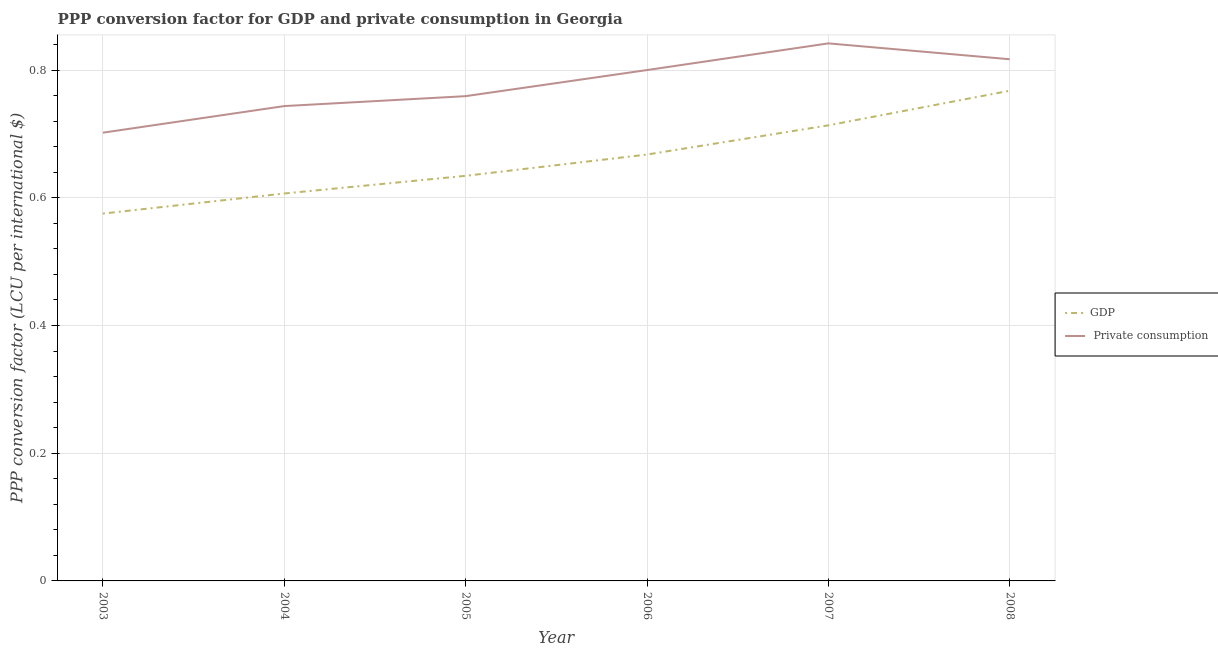What is the ppp conversion factor for gdp in 2003?
Ensure brevity in your answer.  0.58. Across all years, what is the maximum ppp conversion factor for gdp?
Keep it short and to the point. 0.77. Across all years, what is the minimum ppp conversion factor for gdp?
Give a very brief answer. 0.58. What is the total ppp conversion factor for gdp in the graph?
Your answer should be very brief. 3.97. What is the difference between the ppp conversion factor for gdp in 2005 and that in 2006?
Offer a very short reply. -0.03. What is the difference between the ppp conversion factor for gdp in 2003 and the ppp conversion factor for private consumption in 2006?
Your answer should be very brief. -0.22. What is the average ppp conversion factor for gdp per year?
Offer a very short reply. 0.66. In the year 2007, what is the difference between the ppp conversion factor for private consumption and ppp conversion factor for gdp?
Give a very brief answer. 0.13. In how many years, is the ppp conversion factor for gdp greater than 0.32 LCU?
Your response must be concise. 6. What is the ratio of the ppp conversion factor for gdp in 2006 to that in 2008?
Offer a very short reply. 0.87. Is the difference between the ppp conversion factor for gdp in 2005 and 2006 greater than the difference between the ppp conversion factor for private consumption in 2005 and 2006?
Your answer should be very brief. Yes. What is the difference between the highest and the second highest ppp conversion factor for gdp?
Make the answer very short. 0.05. What is the difference between the highest and the lowest ppp conversion factor for private consumption?
Make the answer very short. 0.14. Is the ppp conversion factor for gdp strictly greater than the ppp conversion factor for private consumption over the years?
Ensure brevity in your answer.  No. Is the ppp conversion factor for gdp strictly less than the ppp conversion factor for private consumption over the years?
Give a very brief answer. Yes. How many lines are there?
Make the answer very short. 2. How many years are there in the graph?
Offer a very short reply. 6. Are the values on the major ticks of Y-axis written in scientific E-notation?
Your response must be concise. No. How are the legend labels stacked?
Ensure brevity in your answer.  Vertical. What is the title of the graph?
Your answer should be compact. PPP conversion factor for GDP and private consumption in Georgia. What is the label or title of the X-axis?
Offer a very short reply. Year. What is the label or title of the Y-axis?
Offer a terse response. PPP conversion factor (LCU per international $). What is the PPP conversion factor (LCU per international $) of GDP in 2003?
Offer a terse response. 0.58. What is the PPP conversion factor (LCU per international $) of  Private consumption in 2003?
Offer a very short reply. 0.7. What is the PPP conversion factor (LCU per international $) in GDP in 2004?
Your answer should be very brief. 0.61. What is the PPP conversion factor (LCU per international $) in  Private consumption in 2004?
Provide a succinct answer. 0.74. What is the PPP conversion factor (LCU per international $) in GDP in 2005?
Provide a succinct answer. 0.63. What is the PPP conversion factor (LCU per international $) in  Private consumption in 2005?
Your answer should be very brief. 0.76. What is the PPP conversion factor (LCU per international $) in GDP in 2006?
Provide a succinct answer. 0.67. What is the PPP conversion factor (LCU per international $) in  Private consumption in 2006?
Your response must be concise. 0.8. What is the PPP conversion factor (LCU per international $) in GDP in 2007?
Keep it short and to the point. 0.71. What is the PPP conversion factor (LCU per international $) of  Private consumption in 2007?
Provide a short and direct response. 0.84. What is the PPP conversion factor (LCU per international $) in GDP in 2008?
Ensure brevity in your answer.  0.77. What is the PPP conversion factor (LCU per international $) in  Private consumption in 2008?
Keep it short and to the point. 0.82. Across all years, what is the maximum PPP conversion factor (LCU per international $) in GDP?
Offer a very short reply. 0.77. Across all years, what is the maximum PPP conversion factor (LCU per international $) in  Private consumption?
Your answer should be compact. 0.84. Across all years, what is the minimum PPP conversion factor (LCU per international $) of GDP?
Provide a succinct answer. 0.58. Across all years, what is the minimum PPP conversion factor (LCU per international $) in  Private consumption?
Your answer should be compact. 0.7. What is the total PPP conversion factor (LCU per international $) of GDP in the graph?
Ensure brevity in your answer.  3.97. What is the total PPP conversion factor (LCU per international $) of  Private consumption in the graph?
Make the answer very short. 4.66. What is the difference between the PPP conversion factor (LCU per international $) in GDP in 2003 and that in 2004?
Provide a succinct answer. -0.03. What is the difference between the PPP conversion factor (LCU per international $) of  Private consumption in 2003 and that in 2004?
Your answer should be compact. -0.04. What is the difference between the PPP conversion factor (LCU per international $) of GDP in 2003 and that in 2005?
Give a very brief answer. -0.06. What is the difference between the PPP conversion factor (LCU per international $) of  Private consumption in 2003 and that in 2005?
Ensure brevity in your answer.  -0.06. What is the difference between the PPP conversion factor (LCU per international $) in GDP in 2003 and that in 2006?
Offer a terse response. -0.09. What is the difference between the PPP conversion factor (LCU per international $) in  Private consumption in 2003 and that in 2006?
Ensure brevity in your answer.  -0.1. What is the difference between the PPP conversion factor (LCU per international $) in GDP in 2003 and that in 2007?
Your answer should be compact. -0.14. What is the difference between the PPP conversion factor (LCU per international $) of  Private consumption in 2003 and that in 2007?
Keep it short and to the point. -0.14. What is the difference between the PPP conversion factor (LCU per international $) of GDP in 2003 and that in 2008?
Your answer should be compact. -0.19. What is the difference between the PPP conversion factor (LCU per international $) of  Private consumption in 2003 and that in 2008?
Make the answer very short. -0.12. What is the difference between the PPP conversion factor (LCU per international $) in GDP in 2004 and that in 2005?
Make the answer very short. -0.03. What is the difference between the PPP conversion factor (LCU per international $) in  Private consumption in 2004 and that in 2005?
Offer a terse response. -0.02. What is the difference between the PPP conversion factor (LCU per international $) of GDP in 2004 and that in 2006?
Keep it short and to the point. -0.06. What is the difference between the PPP conversion factor (LCU per international $) in  Private consumption in 2004 and that in 2006?
Provide a succinct answer. -0.06. What is the difference between the PPP conversion factor (LCU per international $) of GDP in 2004 and that in 2007?
Ensure brevity in your answer.  -0.11. What is the difference between the PPP conversion factor (LCU per international $) in  Private consumption in 2004 and that in 2007?
Your answer should be very brief. -0.1. What is the difference between the PPP conversion factor (LCU per international $) of GDP in 2004 and that in 2008?
Provide a succinct answer. -0.16. What is the difference between the PPP conversion factor (LCU per international $) of  Private consumption in 2004 and that in 2008?
Give a very brief answer. -0.07. What is the difference between the PPP conversion factor (LCU per international $) in GDP in 2005 and that in 2006?
Your answer should be compact. -0.03. What is the difference between the PPP conversion factor (LCU per international $) of  Private consumption in 2005 and that in 2006?
Your response must be concise. -0.04. What is the difference between the PPP conversion factor (LCU per international $) in GDP in 2005 and that in 2007?
Ensure brevity in your answer.  -0.08. What is the difference between the PPP conversion factor (LCU per international $) of  Private consumption in 2005 and that in 2007?
Your answer should be compact. -0.08. What is the difference between the PPP conversion factor (LCU per international $) in GDP in 2005 and that in 2008?
Your answer should be compact. -0.13. What is the difference between the PPP conversion factor (LCU per international $) of  Private consumption in 2005 and that in 2008?
Offer a terse response. -0.06. What is the difference between the PPP conversion factor (LCU per international $) of GDP in 2006 and that in 2007?
Offer a terse response. -0.05. What is the difference between the PPP conversion factor (LCU per international $) in  Private consumption in 2006 and that in 2007?
Keep it short and to the point. -0.04. What is the difference between the PPP conversion factor (LCU per international $) in GDP in 2006 and that in 2008?
Your response must be concise. -0.1. What is the difference between the PPP conversion factor (LCU per international $) in  Private consumption in 2006 and that in 2008?
Your answer should be very brief. -0.02. What is the difference between the PPP conversion factor (LCU per international $) in GDP in 2007 and that in 2008?
Give a very brief answer. -0.05. What is the difference between the PPP conversion factor (LCU per international $) in  Private consumption in 2007 and that in 2008?
Your answer should be compact. 0.02. What is the difference between the PPP conversion factor (LCU per international $) in GDP in 2003 and the PPP conversion factor (LCU per international $) in  Private consumption in 2004?
Provide a succinct answer. -0.17. What is the difference between the PPP conversion factor (LCU per international $) of GDP in 2003 and the PPP conversion factor (LCU per international $) of  Private consumption in 2005?
Your response must be concise. -0.18. What is the difference between the PPP conversion factor (LCU per international $) of GDP in 2003 and the PPP conversion factor (LCU per international $) of  Private consumption in 2006?
Offer a very short reply. -0.22. What is the difference between the PPP conversion factor (LCU per international $) of GDP in 2003 and the PPP conversion factor (LCU per international $) of  Private consumption in 2007?
Provide a short and direct response. -0.27. What is the difference between the PPP conversion factor (LCU per international $) in GDP in 2003 and the PPP conversion factor (LCU per international $) in  Private consumption in 2008?
Provide a succinct answer. -0.24. What is the difference between the PPP conversion factor (LCU per international $) in GDP in 2004 and the PPP conversion factor (LCU per international $) in  Private consumption in 2005?
Ensure brevity in your answer.  -0.15. What is the difference between the PPP conversion factor (LCU per international $) in GDP in 2004 and the PPP conversion factor (LCU per international $) in  Private consumption in 2006?
Keep it short and to the point. -0.19. What is the difference between the PPP conversion factor (LCU per international $) of GDP in 2004 and the PPP conversion factor (LCU per international $) of  Private consumption in 2007?
Make the answer very short. -0.24. What is the difference between the PPP conversion factor (LCU per international $) of GDP in 2004 and the PPP conversion factor (LCU per international $) of  Private consumption in 2008?
Give a very brief answer. -0.21. What is the difference between the PPP conversion factor (LCU per international $) of GDP in 2005 and the PPP conversion factor (LCU per international $) of  Private consumption in 2006?
Provide a succinct answer. -0.17. What is the difference between the PPP conversion factor (LCU per international $) of GDP in 2005 and the PPP conversion factor (LCU per international $) of  Private consumption in 2007?
Provide a short and direct response. -0.21. What is the difference between the PPP conversion factor (LCU per international $) of GDP in 2005 and the PPP conversion factor (LCU per international $) of  Private consumption in 2008?
Provide a short and direct response. -0.18. What is the difference between the PPP conversion factor (LCU per international $) of GDP in 2006 and the PPP conversion factor (LCU per international $) of  Private consumption in 2007?
Your answer should be very brief. -0.17. What is the difference between the PPP conversion factor (LCU per international $) in GDP in 2006 and the PPP conversion factor (LCU per international $) in  Private consumption in 2008?
Give a very brief answer. -0.15. What is the difference between the PPP conversion factor (LCU per international $) in GDP in 2007 and the PPP conversion factor (LCU per international $) in  Private consumption in 2008?
Ensure brevity in your answer.  -0.1. What is the average PPP conversion factor (LCU per international $) of GDP per year?
Offer a terse response. 0.66. What is the average PPP conversion factor (LCU per international $) of  Private consumption per year?
Your response must be concise. 0.78. In the year 2003, what is the difference between the PPP conversion factor (LCU per international $) in GDP and PPP conversion factor (LCU per international $) in  Private consumption?
Offer a terse response. -0.13. In the year 2004, what is the difference between the PPP conversion factor (LCU per international $) of GDP and PPP conversion factor (LCU per international $) of  Private consumption?
Give a very brief answer. -0.14. In the year 2005, what is the difference between the PPP conversion factor (LCU per international $) of GDP and PPP conversion factor (LCU per international $) of  Private consumption?
Ensure brevity in your answer.  -0.12. In the year 2006, what is the difference between the PPP conversion factor (LCU per international $) in GDP and PPP conversion factor (LCU per international $) in  Private consumption?
Your response must be concise. -0.13. In the year 2007, what is the difference between the PPP conversion factor (LCU per international $) of GDP and PPP conversion factor (LCU per international $) of  Private consumption?
Keep it short and to the point. -0.13. In the year 2008, what is the difference between the PPP conversion factor (LCU per international $) of GDP and PPP conversion factor (LCU per international $) of  Private consumption?
Your response must be concise. -0.05. What is the ratio of the PPP conversion factor (LCU per international $) of GDP in 2003 to that in 2004?
Your response must be concise. 0.95. What is the ratio of the PPP conversion factor (LCU per international $) of  Private consumption in 2003 to that in 2004?
Ensure brevity in your answer.  0.94. What is the ratio of the PPP conversion factor (LCU per international $) of GDP in 2003 to that in 2005?
Ensure brevity in your answer.  0.91. What is the ratio of the PPP conversion factor (LCU per international $) in  Private consumption in 2003 to that in 2005?
Your answer should be compact. 0.92. What is the ratio of the PPP conversion factor (LCU per international $) of GDP in 2003 to that in 2006?
Provide a succinct answer. 0.86. What is the ratio of the PPP conversion factor (LCU per international $) in  Private consumption in 2003 to that in 2006?
Your answer should be compact. 0.88. What is the ratio of the PPP conversion factor (LCU per international $) in GDP in 2003 to that in 2007?
Provide a short and direct response. 0.81. What is the ratio of the PPP conversion factor (LCU per international $) in  Private consumption in 2003 to that in 2007?
Provide a short and direct response. 0.83. What is the ratio of the PPP conversion factor (LCU per international $) in GDP in 2003 to that in 2008?
Your response must be concise. 0.75. What is the ratio of the PPP conversion factor (LCU per international $) in  Private consumption in 2003 to that in 2008?
Offer a very short reply. 0.86. What is the ratio of the PPP conversion factor (LCU per international $) in GDP in 2004 to that in 2005?
Keep it short and to the point. 0.96. What is the ratio of the PPP conversion factor (LCU per international $) of  Private consumption in 2004 to that in 2005?
Give a very brief answer. 0.98. What is the ratio of the PPP conversion factor (LCU per international $) of GDP in 2004 to that in 2006?
Ensure brevity in your answer.  0.91. What is the ratio of the PPP conversion factor (LCU per international $) in  Private consumption in 2004 to that in 2006?
Ensure brevity in your answer.  0.93. What is the ratio of the PPP conversion factor (LCU per international $) of GDP in 2004 to that in 2007?
Provide a short and direct response. 0.85. What is the ratio of the PPP conversion factor (LCU per international $) of  Private consumption in 2004 to that in 2007?
Your answer should be compact. 0.88. What is the ratio of the PPP conversion factor (LCU per international $) in GDP in 2004 to that in 2008?
Provide a succinct answer. 0.79. What is the ratio of the PPP conversion factor (LCU per international $) of  Private consumption in 2004 to that in 2008?
Your answer should be compact. 0.91. What is the ratio of the PPP conversion factor (LCU per international $) in GDP in 2005 to that in 2006?
Ensure brevity in your answer.  0.95. What is the ratio of the PPP conversion factor (LCU per international $) of  Private consumption in 2005 to that in 2006?
Provide a succinct answer. 0.95. What is the ratio of the PPP conversion factor (LCU per international $) of GDP in 2005 to that in 2007?
Your answer should be compact. 0.89. What is the ratio of the PPP conversion factor (LCU per international $) of  Private consumption in 2005 to that in 2007?
Your answer should be very brief. 0.9. What is the ratio of the PPP conversion factor (LCU per international $) in GDP in 2005 to that in 2008?
Offer a terse response. 0.83. What is the ratio of the PPP conversion factor (LCU per international $) in  Private consumption in 2005 to that in 2008?
Provide a short and direct response. 0.93. What is the ratio of the PPP conversion factor (LCU per international $) of GDP in 2006 to that in 2007?
Offer a very short reply. 0.94. What is the ratio of the PPP conversion factor (LCU per international $) in  Private consumption in 2006 to that in 2007?
Give a very brief answer. 0.95. What is the ratio of the PPP conversion factor (LCU per international $) in GDP in 2006 to that in 2008?
Make the answer very short. 0.87. What is the ratio of the PPP conversion factor (LCU per international $) of  Private consumption in 2006 to that in 2008?
Ensure brevity in your answer.  0.98. What is the ratio of the PPP conversion factor (LCU per international $) in GDP in 2007 to that in 2008?
Provide a succinct answer. 0.93. What is the ratio of the PPP conversion factor (LCU per international $) of  Private consumption in 2007 to that in 2008?
Your answer should be very brief. 1.03. What is the difference between the highest and the second highest PPP conversion factor (LCU per international $) in GDP?
Ensure brevity in your answer.  0.05. What is the difference between the highest and the second highest PPP conversion factor (LCU per international $) in  Private consumption?
Offer a very short reply. 0.02. What is the difference between the highest and the lowest PPP conversion factor (LCU per international $) in GDP?
Give a very brief answer. 0.19. What is the difference between the highest and the lowest PPP conversion factor (LCU per international $) of  Private consumption?
Give a very brief answer. 0.14. 